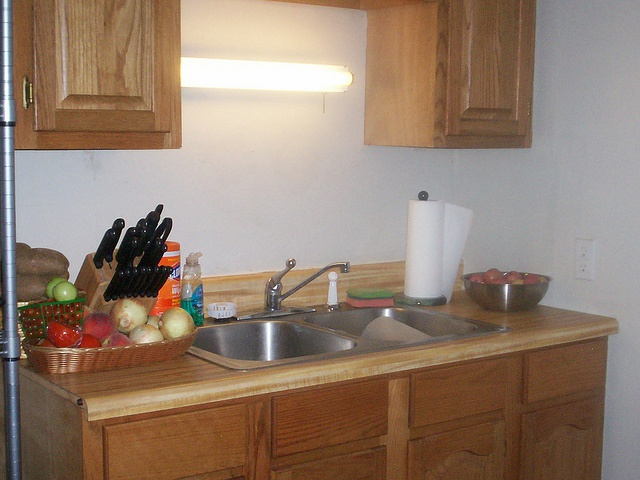Describe the objects in this image and their specific colors. I can see sink in black and gray tones, bowl in black, gray, maroon, and brown tones, apple in black, brown, and maroon tones, bottle in black, darkgray, teal, tan, and gray tones, and knife in black, red, maroon, and lightgray tones in this image. 